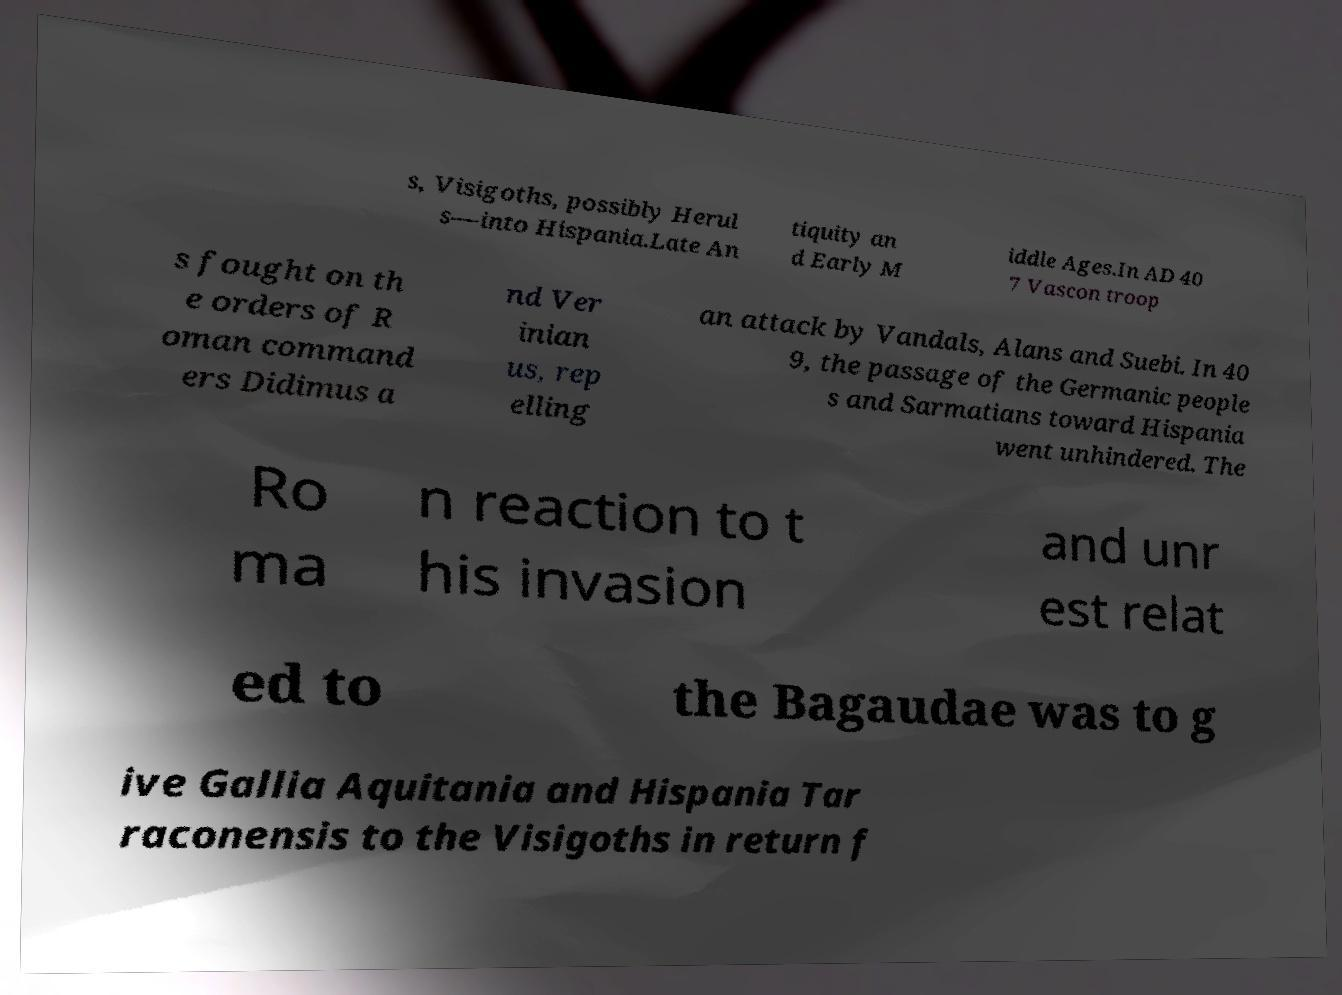I need the written content from this picture converted into text. Can you do that? s, Visigoths, possibly Herul s—into Hispania.Late An tiquity an d Early M iddle Ages.In AD 40 7 Vascon troop s fought on th e orders of R oman command ers Didimus a nd Ver inian us, rep elling an attack by Vandals, Alans and Suebi. In 40 9, the passage of the Germanic people s and Sarmatians toward Hispania went unhindered. The Ro ma n reaction to t his invasion and unr est relat ed to the Bagaudae was to g ive Gallia Aquitania and Hispania Tar raconensis to the Visigoths in return f 